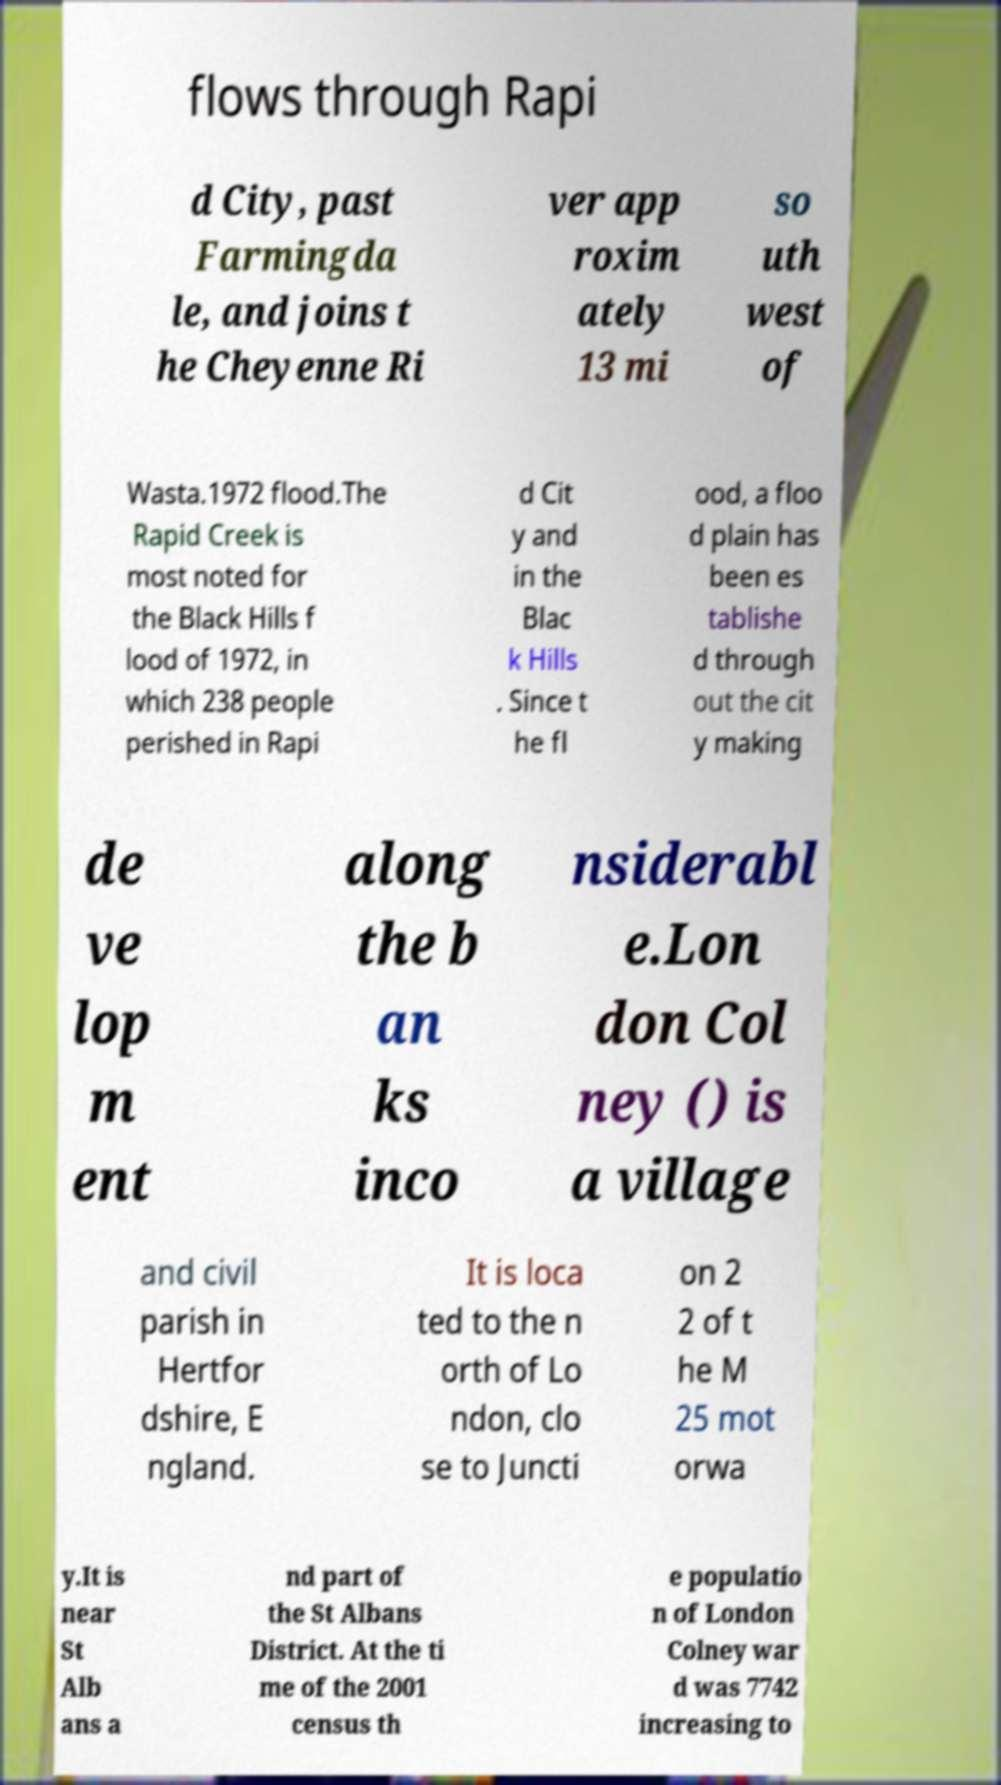For documentation purposes, I need the text within this image transcribed. Could you provide that? flows through Rapi d City, past Farmingda le, and joins t he Cheyenne Ri ver app roxim ately 13 mi so uth west of Wasta.1972 flood.The Rapid Creek is most noted for the Black Hills f lood of 1972, in which 238 people perished in Rapi d Cit y and in the Blac k Hills . Since t he fl ood, a floo d plain has been es tablishe d through out the cit y making de ve lop m ent along the b an ks inco nsiderabl e.Lon don Col ney () is a village and civil parish in Hertfor dshire, E ngland. It is loca ted to the n orth of Lo ndon, clo se to Juncti on 2 2 of t he M 25 mot orwa y.It is near St Alb ans a nd part of the St Albans District. At the ti me of the 2001 census th e populatio n of London Colney war d was 7742 increasing to 